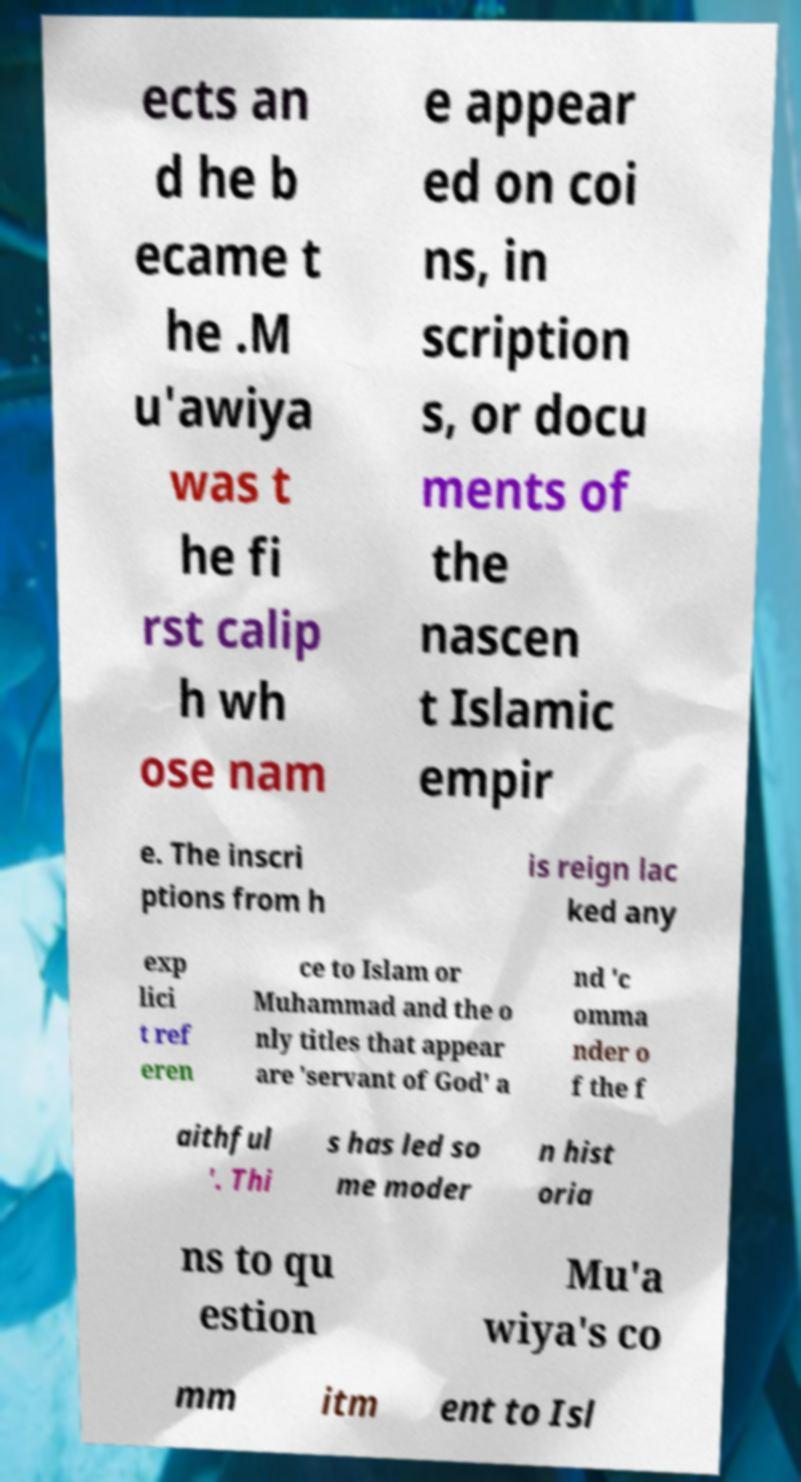Can you accurately transcribe the text from the provided image for me? ects an d he b ecame t he .M u'awiya was t he fi rst calip h wh ose nam e appear ed on coi ns, in scription s, or docu ments of the nascen t Islamic empir e. The inscri ptions from h is reign lac ked any exp lici t ref eren ce to Islam or Muhammad and the o nly titles that appear are 'servant of God' a nd 'c omma nder o f the f aithful '. Thi s has led so me moder n hist oria ns to qu estion Mu'a wiya's co mm itm ent to Isl 